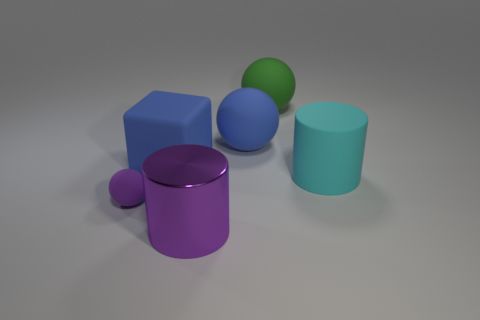What size is the cylinder that is made of the same material as the small thing?
Keep it short and to the point. Large. What size is the blue matte object that is the same shape as the small purple thing?
Make the answer very short. Large. What number of brown blocks have the same material as the cyan cylinder?
Your answer should be compact. 0. What is the material of the large purple thing?
Offer a very short reply. Metal. What is the shape of the blue matte object to the right of the cylinder in front of the small purple thing?
Give a very brief answer. Sphere. The rubber object in front of the large cyan cylinder has what shape?
Make the answer very short. Sphere. How many cylinders have the same color as the tiny rubber ball?
Your answer should be very brief. 1. The shiny thing has what color?
Make the answer very short. Purple. How many green matte objects are on the left side of the blue matte object that is to the left of the big blue sphere?
Provide a short and direct response. 0. There is a cyan thing; is its size the same as the object that is in front of the small purple thing?
Ensure brevity in your answer.  Yes. 